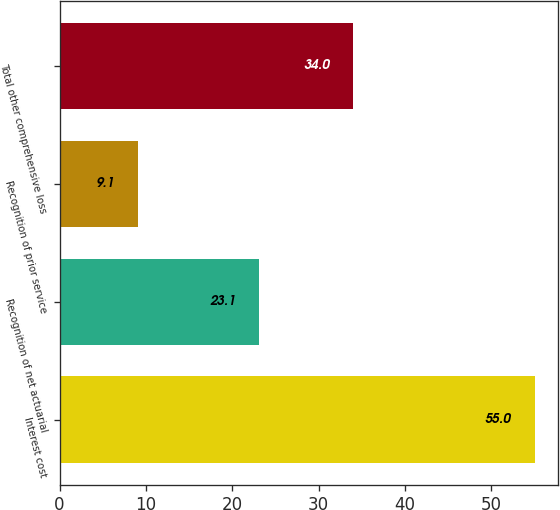Convert chart to OTSL. <chart><loc_0><loc_0><loc_500><loc_500><bar_chart><fcel>Interest cost<fcel>Recognition of net actuarial<fcel>Recognition of prior service<fcel>Total other comprehensive loss<nl><fcel>55<fcel>23.1<fcel>9.1<fcel>34<nl></chart> 